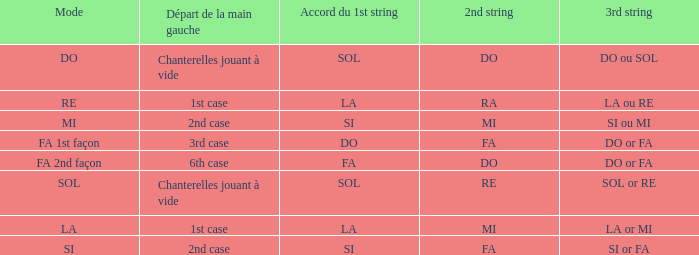For a 1st string of si accord du and a 2nd string of mi, what is the third string? SI ou MI. 